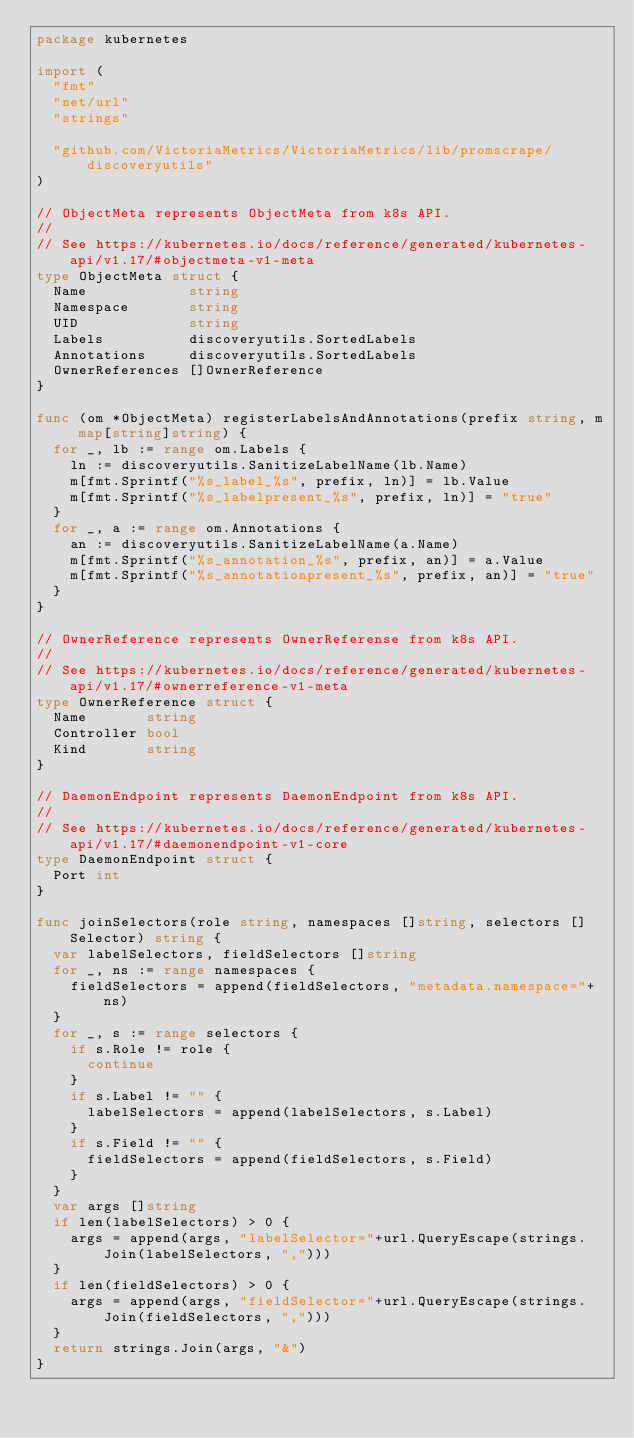Convert code to text. <code><loc_0><loc_0><loc_500><loc_500><_Go_>package kubernetes

import (
	"fmt"
	"net/url"
	"strings"

	"github.com/VictoriaMetrics/VictoriaMetrics/lib/promscrape/discoveryutils"
)

// ObjectMeta represents ObjectMeta from k8s API.
//
// See https://kubernetes.io/docs/reference/generated/kubernetes-api/v1.17/#objectmeta-v1-meta
type ObjectMeta struct {
	Name            string
	Namespace       string
	UID             string
	Labels          discoveryutils.SortedLabels
	Annotations     discoveryutils.SortedLabels
	OwnerReferences []OwnerReference
}

func (om *ObjectMeta) registerLabelsAndAnnotations(prefix string, m map[string]string) {
	for _, lb := range om.Labels {
		ln := discoveryutils.SanitizeLabelName(lb.Name)
		m[fmt.Sprintf("%s_label_%s", prefix, ln)] = lb.Value
		m[fmt.Sprintf("%s_labelpresent_%s", prefix, ln)] = "true"
	}
	for _, a := range om.Annotations {
		an := discoveryutils.SanitizeLabelName(a.Name)
		m[fmt.Sprintf("%s_annotation_%s", prefix, an)] = a.Value
		m[fmt.Sprintf("%s_annotationpresent_%s", prefix, an)] = "true"
	}
}

// OwnerReference represents OwnerReferense from k8s API.
//
// See https://kubernetes.io/docs/reference/generated/kubernetes-api/v1.17/#ownerreference-v1-meta
type OwnerReference struct {
	Name       string
	Controller bool
	Kind       string
}

// DaemonEndpoint represents DaemonEndpoint from k8s API.
//
// See https://kubernetes.io/docs/reference/generated/kubernetes-api/v1.17/#daemonendpoint-v1-core
type DaemonEndpoint struct {
	Port int
}

func joinSelectors(role string, namespaces []string, selectors []Selector) string {
	var labelSelectors, fieldSelectors []string
	for _, ns := range namespaces {
		fieldSelectors = append(fieldSelectors, "metadata.namespace="+ns)
	}
	for _, s := range selectors {
		if s.Role != role {
			continue
		}
		if s.Label != "" {
			labelSelectors = append(labelSelectors, s.Label)
		}
		if s.Field != "" {
			fieldSelectors = append(fieldSelectors, s.Field)
		}
	}
	var args []string
	if len(labelSelectors) > 0 {
		args = append(args, "labelSelector="+url.QueryEscape(strings.Join(labelSelectors, ",")))
	}
	if len(fieldSelectors) > 0 {
		args = append(args, "fieldSelector="+url.QueryEscape(strings.Join(fieldSelectors, ",")))
	}
	return strings.Join(args, "&")
}
</code> 